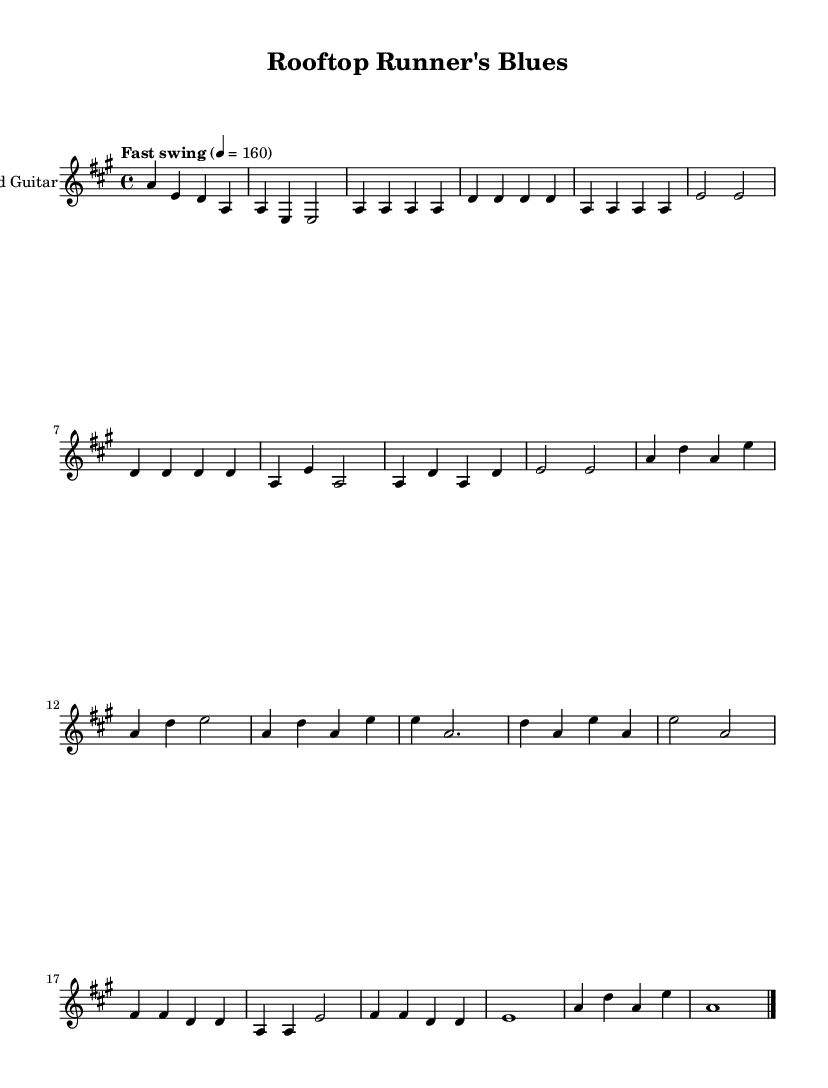What is the key signature of this music? The key signature is A major, which has three sharps: F#, C#, and G#. This can be identified by looking at the key signature at the beginning of the staff.
Answer: A major What is the time signature of this piece? The time signature is 4/4, indicated at the beginning of the score. This means there are four beats per measure and a quarter note receives one beat.
Answer: 4/4 What is the tempo indication given in the sheet music? The tempo is indicated as "Fast swing" with a metronome marking of 4 = 160. This suggests a lively and swinging rhythm at a speed of 160 beats per minute.
Answer: Fast swing How many measures are in the chorus section? The chorus consists of four measures, which can be counted by observing the section between the introductory and bridge parts, marked consistently in the score.
Answer: 4 What is the final note of the outro? The final note of the outro is A, which is indicated by the note that is held through the bar line before the final double bar line.
Answer: A What is the chord progression suggested in the verse? The chord progression in the verse alternates between A major and D major, primarily repeating these two chords throughout. This can be discerned by looking at the notes being played and how they align with common blues structures.
Answer: A and D What type of swing feel is indicated for the music? The music is marked for a "Fast swing" feel, which suggests a lively and rhythmic interpretation typical of blues style. The phrase indicates a specific groove and character expected in the performance.
Answer: Fast swing 